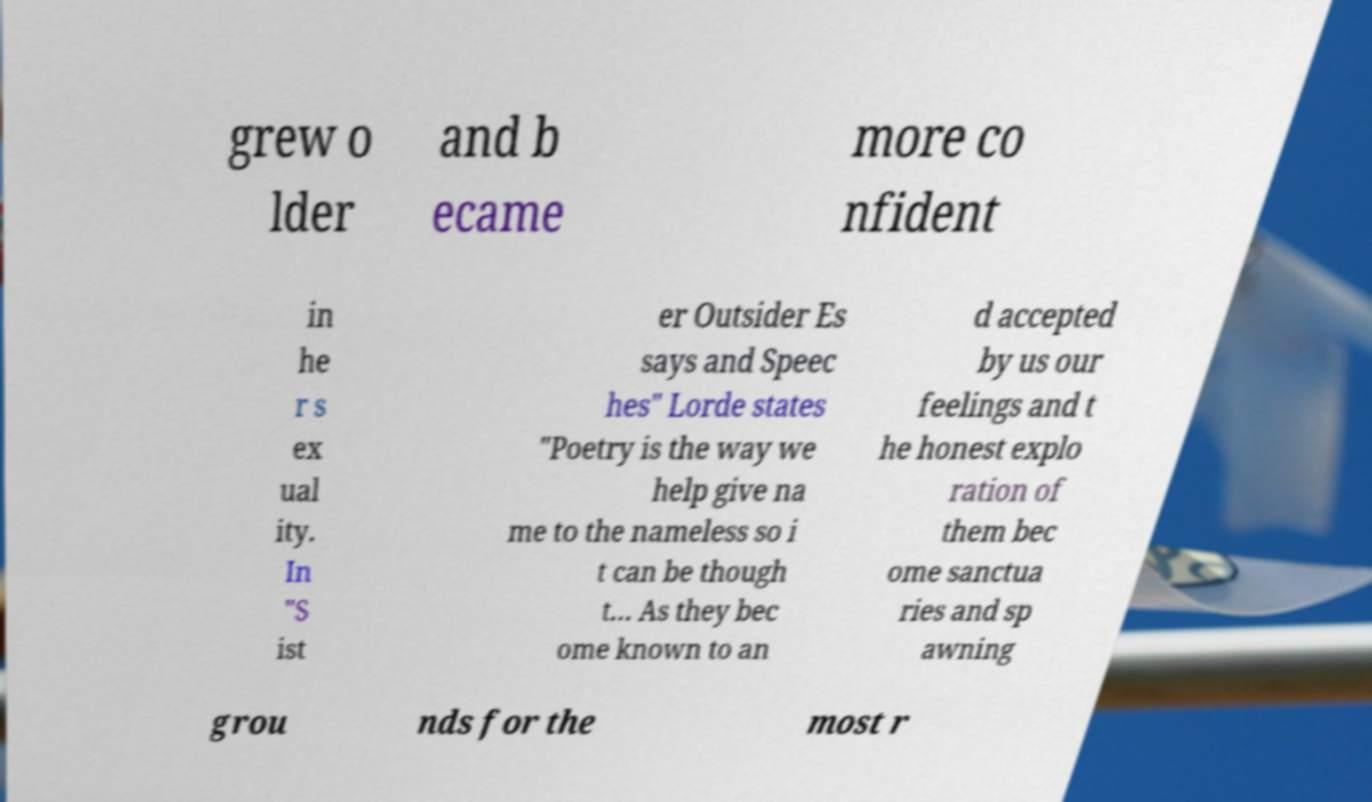Could you assist in decoding the text presented in this image and type it out clearly? grew o lder and b ecame more co nfident in he r s ex ual ity. In "S ist er Outsider Es says and Speec hes" Lorde states "Poetry is the way we help give na me to the nameless so i t can be though t… As they bec ome known to an d accepted by us our feelings and t he honest explo ration of them bec ome sanctua ries and sp awning grou nds for the most r 